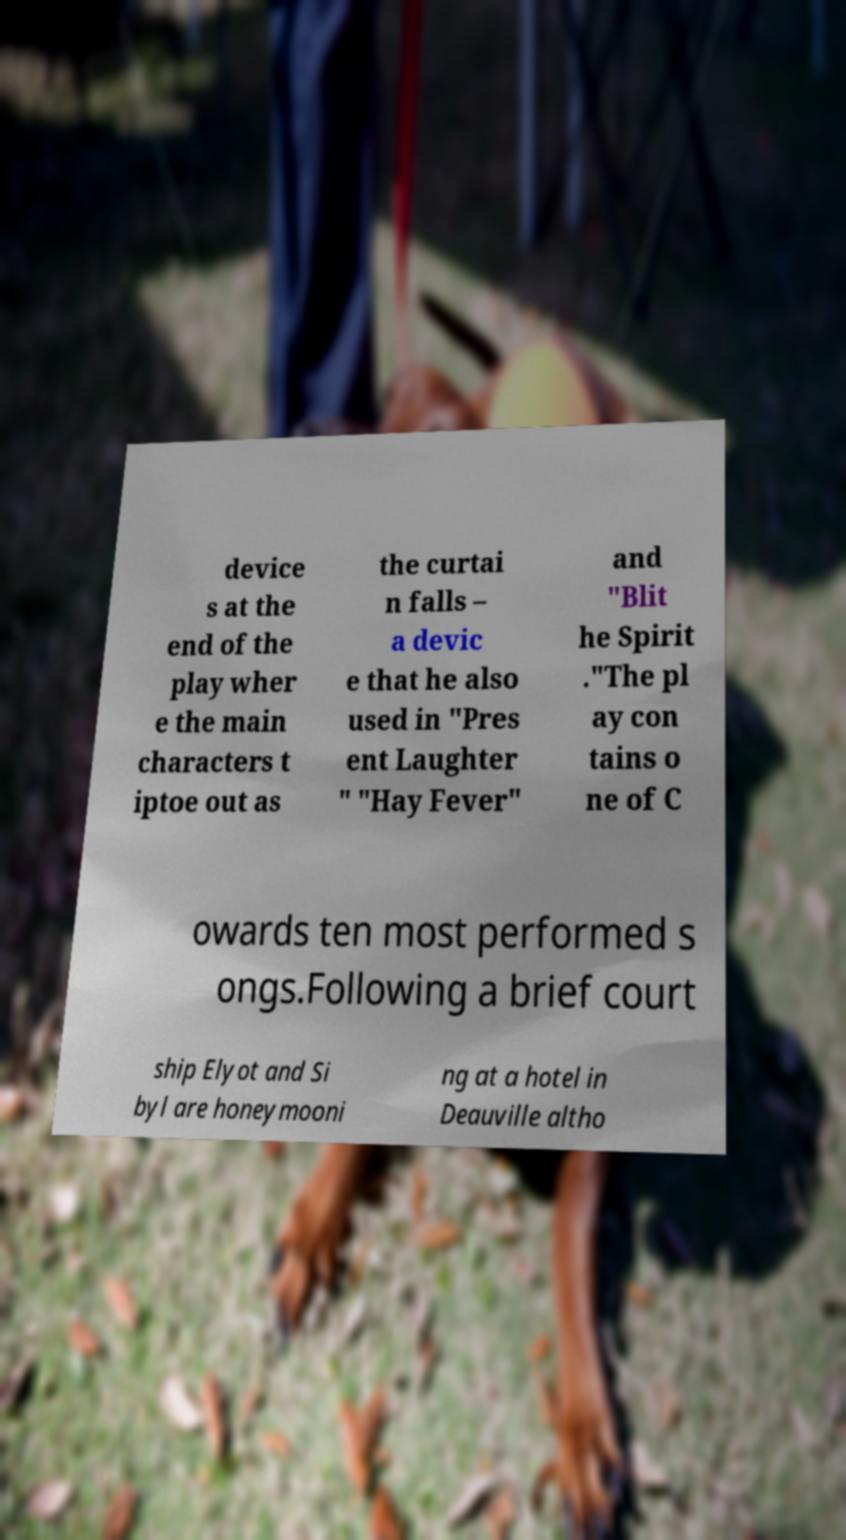For documentation purposes, I need the text within this image transcribed. Could you provide that? device s at the end of the play wher e the main characters t iptoe out as the curtai n falls – a devic e that he also used in "Pres ent Laughter " "Hay Fever" and "Blit he Spirit ."The pl ay con tains o ne of C owards ten most performed s ongs.Following a brief court ship Elyot and Si byl are honeymooni ng at a hotel in Deauville altho 